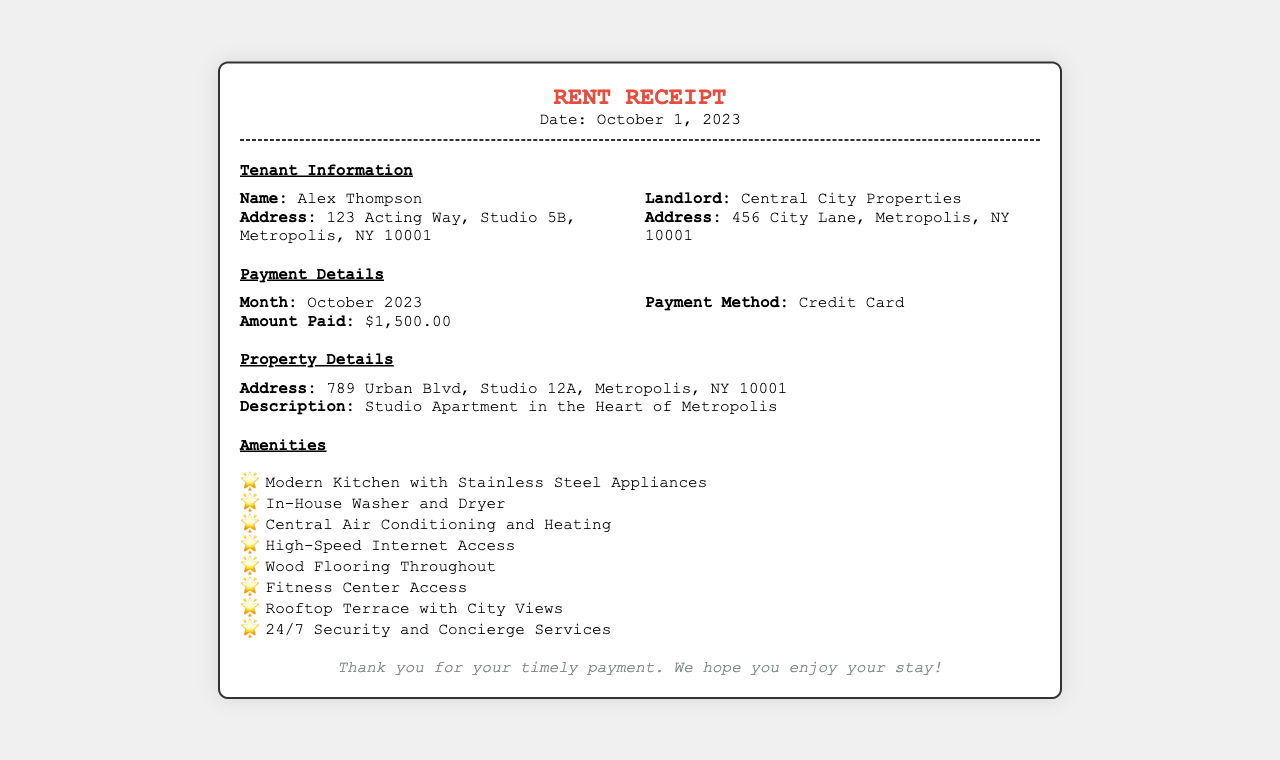What is the tenant's name? The tenant's name is provided in the document, specifically under Tenant Information.
Answer: Alex Thompson What is the amount paid for October 2023? The amount paid is listed in the Payment Details section of the document.
Answer: $1,500.00 Who is the landlord? The landlord's name is mentioned in the Tenant Information section.
Answer: Central City Properties What amenities include high-speed internet access? High-speed internet access is one of the amenities listed in the Amenities section.
Answer: Yes What is the address of the property? The property's address is detailed in the Property Details section of the document.
Answer: 789 Urban Blvd, Studio 12A, Metropolis, NY 10001 How many amenities are listed in total? The total number of amenities can be counted from the Amenities list.
Answer: Eight What payment method was used? The method of payment is specified in the Payment Details of the document.
Answer: Credit Card What is the purpose of this document? The document serves as a record of payment made for rent.
Answer: Rent Receipt 